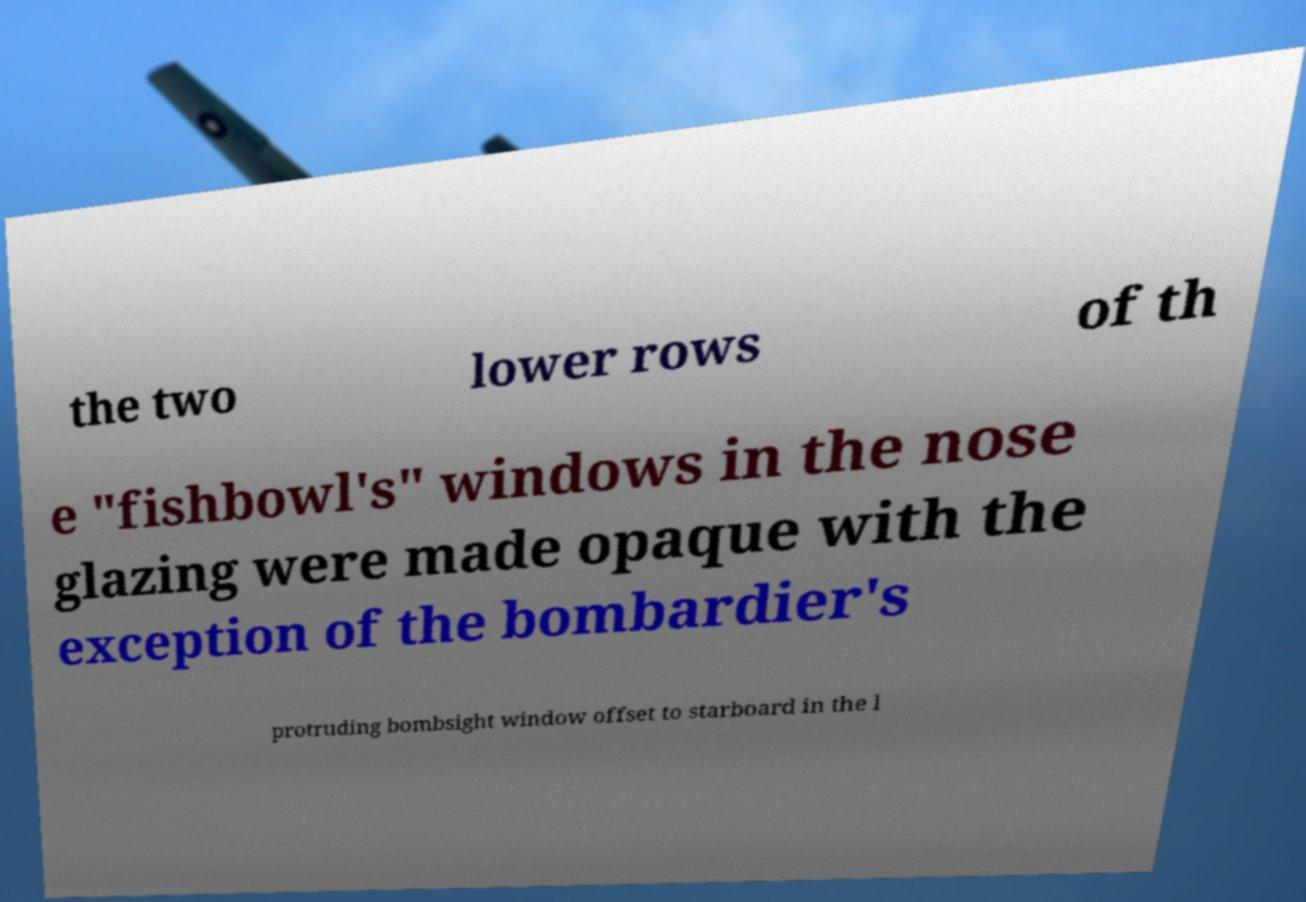Could you extract and type out the text from this image? the two lower rows of th e "fishbowl's" windows in the nose glazing were made opaque with the exception of the bombardier's protruding bombsight window offset to starboard in the l 